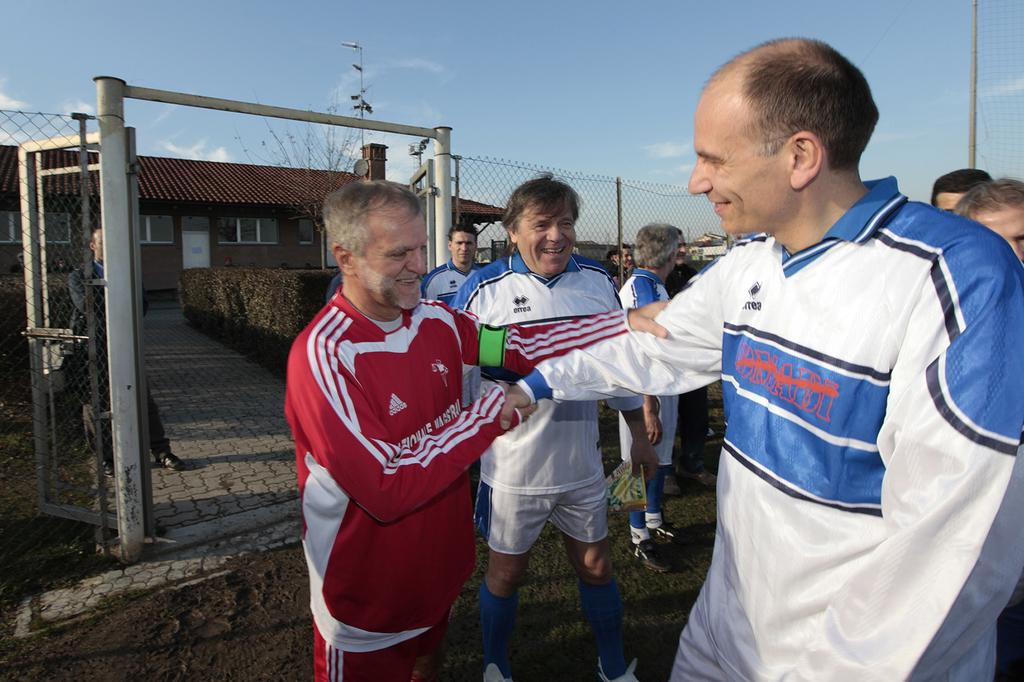<image>
Summarize the visual content of the image. A balding man is happily greeted by a friend in a red Adidas track suit. 